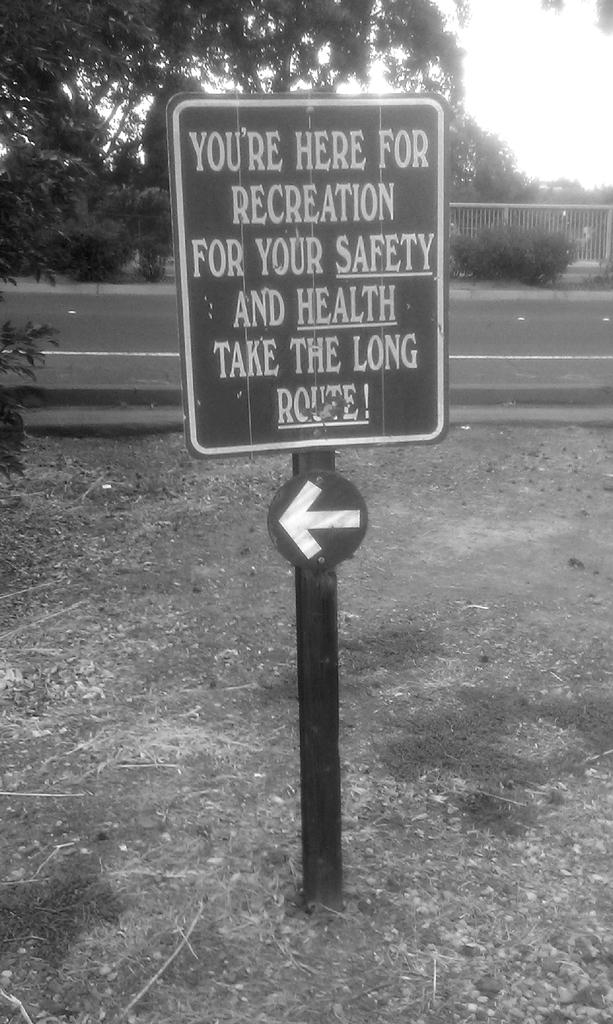What is attached to the pole in the image? There is a board attached to a pole in the image. What can be seen in the background of the image? There are trees in the background of the image. What type of structure is visible in the image? There is railing visible in the image. What is visible at the top of the image? The sky is visible in the image. What is the color scheme of the image? The image is in black and white. How does the board shake in the image? The board does not shake in the image; it is stationary and attached to the pole. What type of expansion is visible in the image? There is no expansion visible in the image; it features a board attached to a pole, trees in the background, railing, and a black and white color scheme. 